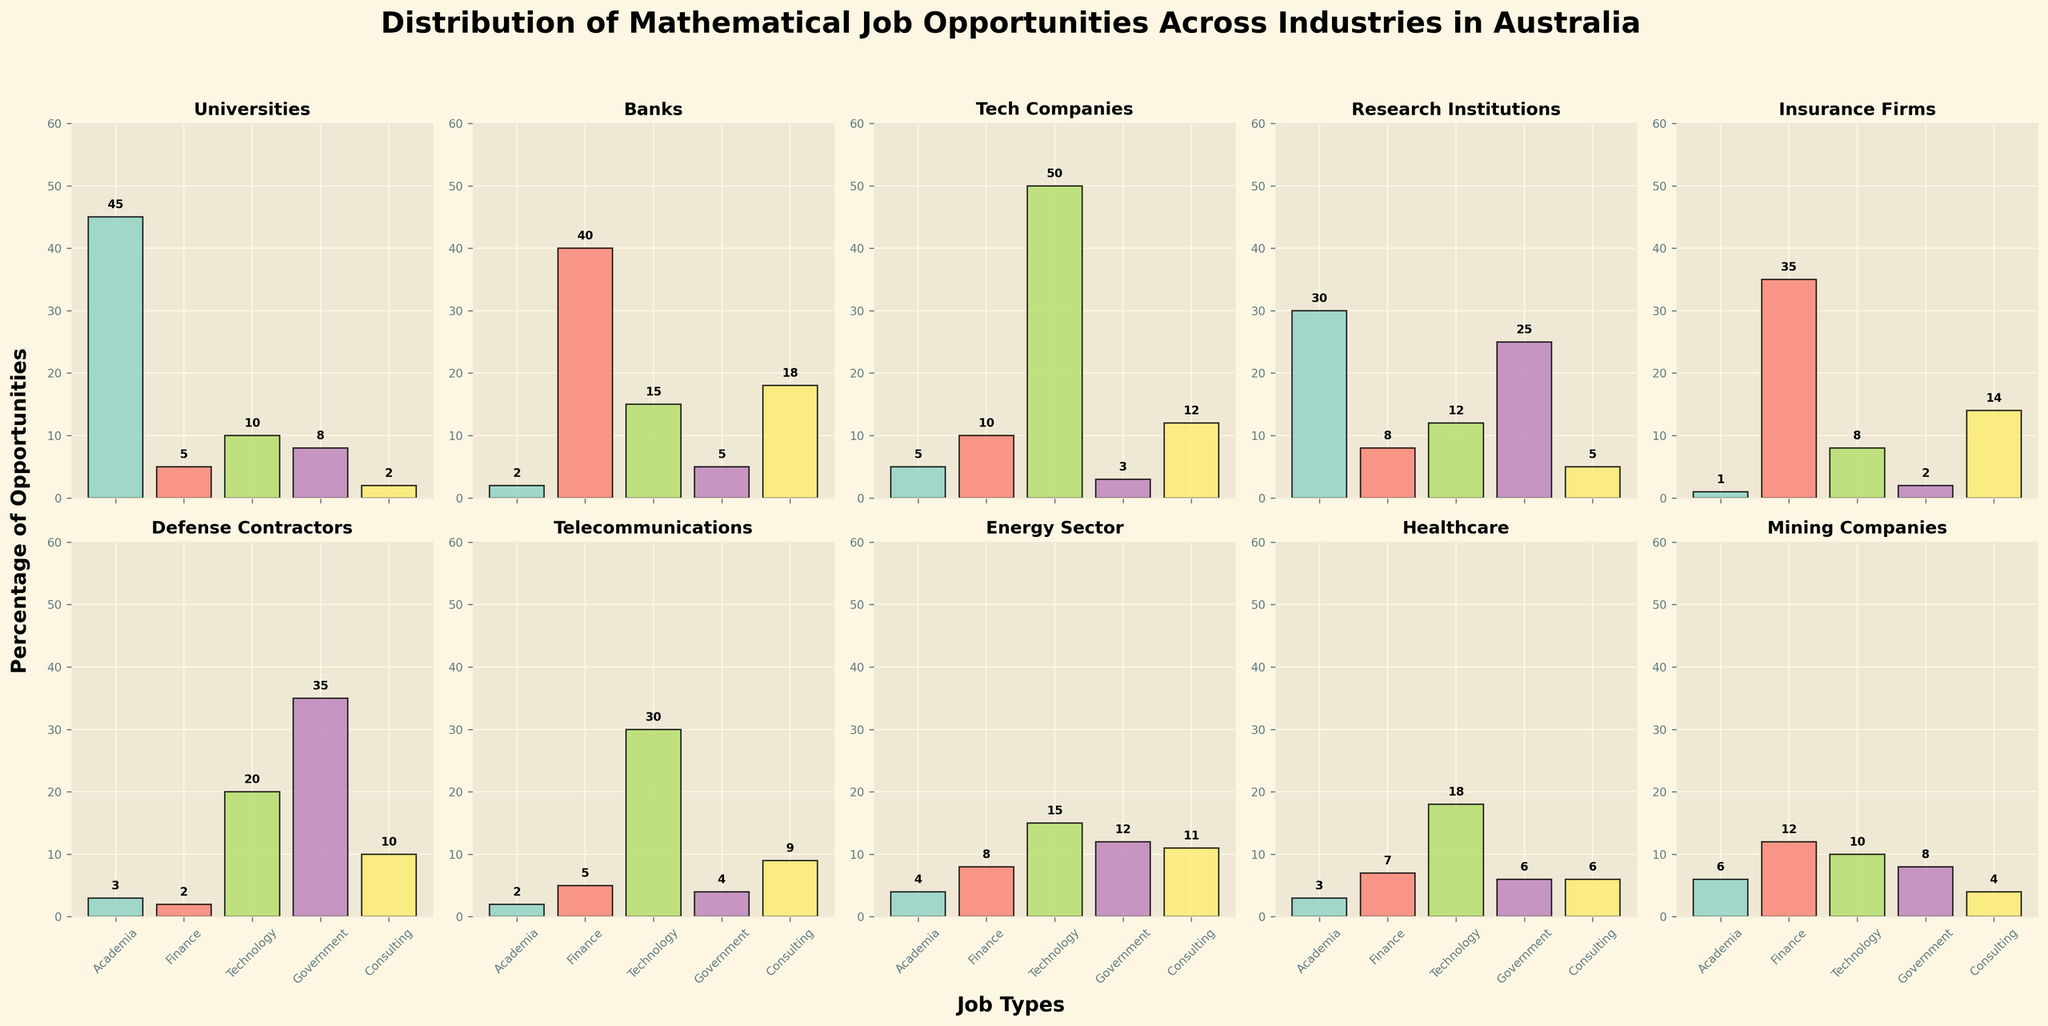what's the title of the figure? The title of the figure is shown at the top of the plot and summarizes the information provided by the visual data. The exact wording of the title is: "Distribution of Mathematical Job Opportunities Across Industries in Australia".
Answer: Distribution of Mathematical Job Opportunities Across Industries in Australia which industry has the highest percentage of opportunities in Academia? To determine the industry with the highest percentage of opportunities in Academia, look at the height of the bars in the category "Academia" across all subplots. The tallest bar corresponds to "Universities" at 45%.
Answer: Universities which two industries have the most similar distribution of opportunities in Technology jobs? Compare the heights of the bars in the "Technology" category for every industry. The two most similar bars represent the corresponding industries. "Tech Companies" and "Telecommunications" both have similar bars, 50% and 30% respectively.
Answer: Tech Companies and Telecommunications which job category has the highest percentage in Defense Contractors? Observe the bars in the subplot for "Defense Contractors" and identify the tallest bar. The "Government" category has the highest percentage at 35%.
Answer: Government how many industries provide more than 10% of opportunities in Consulting? Count the subplots where the "Consulting" bar exceeds the 10% height mark. The industries are "Banks," "Tech Companies," "Insurance Firms," and "Defense Contractors," for a total of 4 industries.
Answer: 4 which industry has the smallest percentage of opportunities in Finance? To find the smallest percentage in Finance, compare the Finance bars in all subplots. The smallest percentage is found in "Universities" at 5%.
Answer: Universities sum of percentages for all job opportunities in Mining Companies? Add up the heights of all bars in the subplot for "Mining Companies": 6 (Academia) + 12 (Finance) + 10 (Technology) + 8 (Government) + 4 (Consulting) = 40%.
Answer: 40% what is the average percentage of Government jobs across all industries? Sum the percentages of Government jobs from all subplots and divide by the number of industries. (8 + 5 + 3 + 25 + 2 + 35 + 4 + 12 + 6 + 8) / 10 = 10.8%.
Answer: 10.8% which industry provides more Finance opportunities, Banks or Insurance Firms? Directly compare the heights of the "Finance" bars in the Banks and Insurance Firms subplots. Banks have a percentage of 40%, while Insurance Firms have 35%.
Answer: Banks 